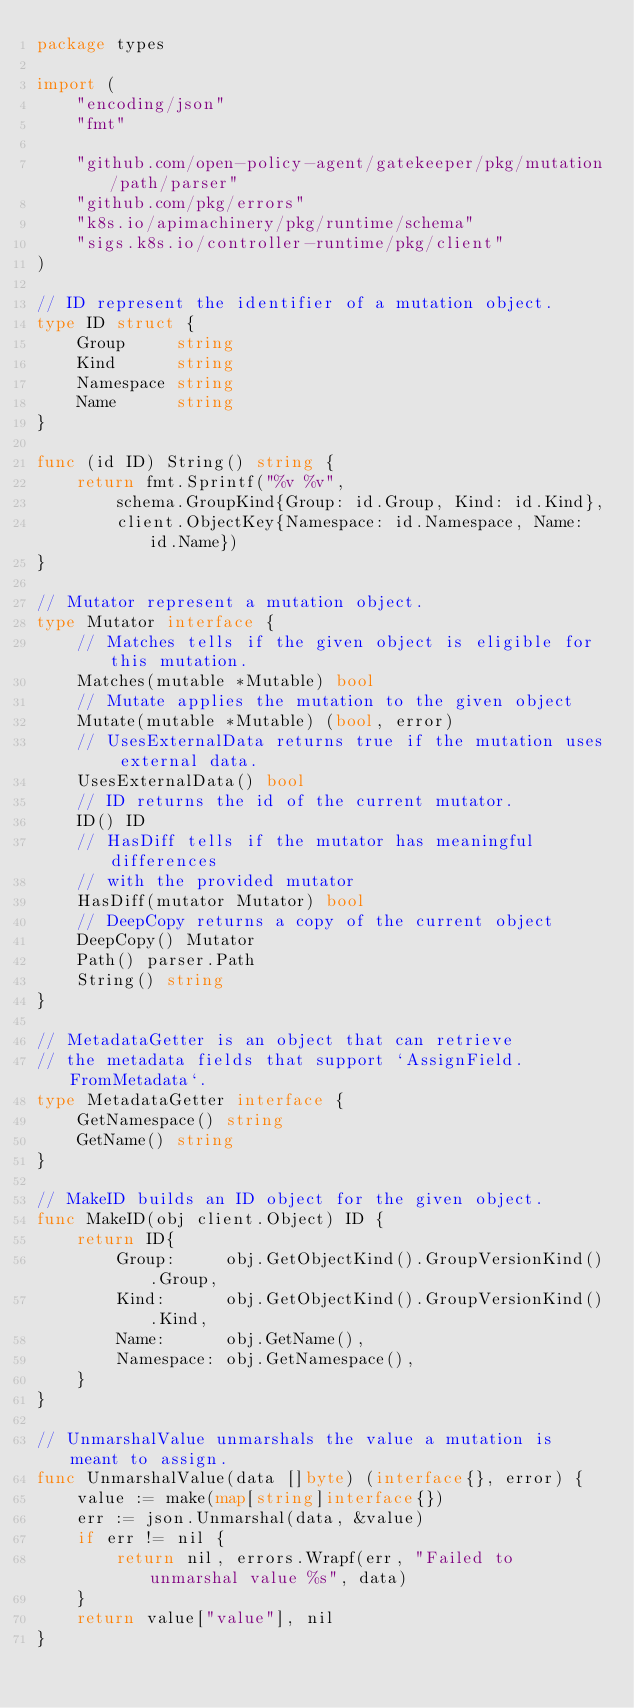<code> <loc_0><loc_0><loc_500><loc_500><_Go_>package types

import (
	"encoding/json"
	"fmt"

	"github.com/open-policy-agent/gatekeeper/pkg/mutation/path/parser"
	"github.com/pkg/errors"
	"k8s.io/apimachinery/pkg/runtime/schema"
	"sigs.k8s.io/controller-runtime/pkg/client"
)

// ID represent the identifier of a mutation object.
type ID struct {
	Group     string
	Kind      string
	Namespace string
	Name      string
}

func (id ID) String() string {
	return fmt.Sprintf("%v %v",
		schema.GroupKind{Group: id.Group, Kind: id.Kind},
		client.ObjectKey{Namespace: id.Namespace, Name: id.Name})
}

// Mutator represent a mutation object.
type Mutator interface {
	// Matches tells if the given object is eligible for this mutation.
	Matches(mutable *Mutable) bool
	// Mutate applies the mutation to the given object
	Mutate(mutable *Mutable) (bool, error)
	// UsesExternalData returns true if the mutation uses external data.
	UsesExternalData() bool
	// ID returns the id of the current mutator.
	ID() ID
	// HasDiff tells if the mutator has meaningful differences
	// with the provided mutator
	HasDiff(mutator Mutator) bool
	// DeepCopy returns a copy of the current object
	DeepCopy() Mutator
	Path() parser.Path
	String() string
}

// MetadataGetter is an object that can retrieve
// the metadata fields that support `AssignField.FromMetadata`.
type MetadataGetter interface {
	GetNamespace() string
	GetName() string
}

// MakeID builds an ID object for the given object.
func MakeID(obj client.Object) ID {
	return ID{
		Group:     obj.GetObjectKind().GroupVersionKind().Group,
		Kind:      obj.GetObjectKind().GroupVersionKind().Kind,
		Name:      obj.GetName(),
		Namespace: obj.GetNamespace(),
	}
}

// UnmarshalValue unmarshals the value a mutation is meant to assign.
func UnmarshalValue(data []byte) (interface{}, error) {
	value := make(map[string]interface{})
	err := json.Unmarshal(data, &value)
	if err != nil {
		return nil, errors.Wrapf(err, "Failed to unmarshal value %s", data)
	}
	return value["value"], nil
}
</code> 